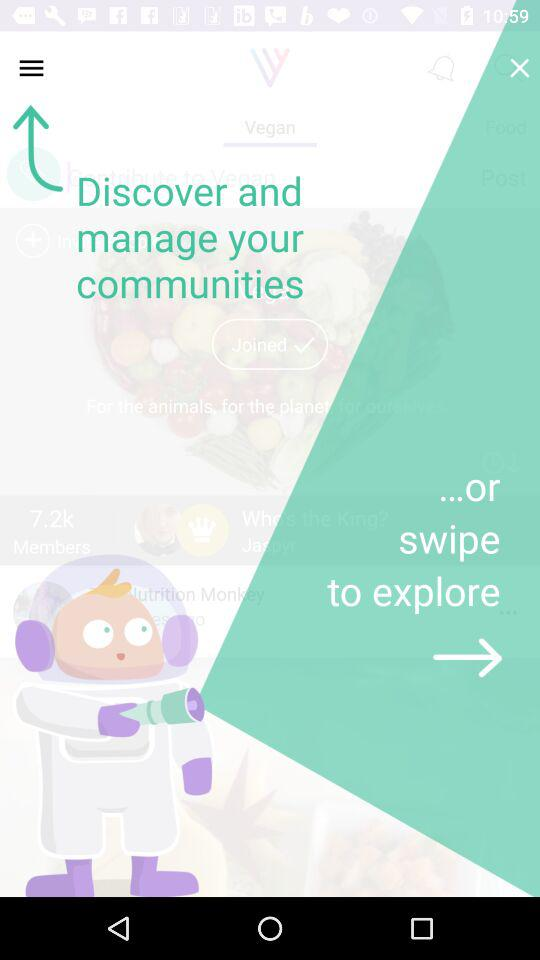How many login options are there?
Answer the question using a single word or phrase. 4 